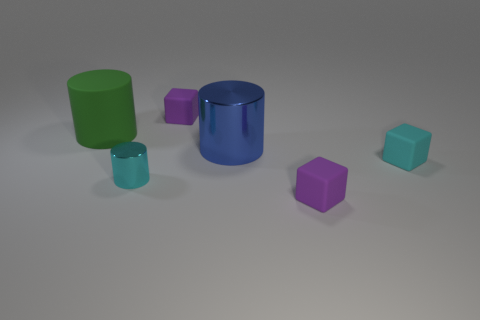There is a big blue thing; does it have the same shape as the tiny purple thing behind the large metal object?
Offer a very short reply. No. What material is the tiny cyan cylinder?
Ensure brevity in your answer.  Metal. The block that is in front of the tiny cube that is to the right of the purple object that is in front of the large blue shiny cylinder is what color?
Your answer should be compact. Purple. What material is the other big thing that is the same shape as the blue thing?
Give a very brief answer. Rubber. How many purple things are the same size as the cyan metal cylinder?
Provide a short and direct response. 2. What number of cyan metal objects are there?
Ensure brevity in your answer.  1. Are the small cylinder and the purple thing behind the small metallic cylinder made of the same material?
Ensure brevity in your answer.  No. How many gray objects are either rubber things or cubes?
Provide a succinct answer. 0. What size is the other blue cylinder that is the same material as the tiny cylinder?
Ensure brevity in your answer.  Large. What number of other small cyan metal objects have the same shape as the tiny cyan shiny thing?
Give a very brief answer. 0. 